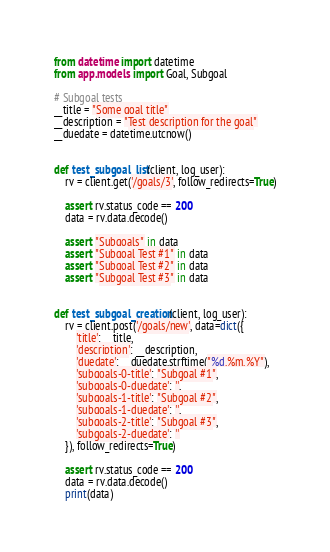<code> <loc_0><loc_0><loc_500><loc_500><_Python_>from datetime import datetime
from app.models import Goal, Subgoal

# Subgoal tests
__title = "Some goal title"
__description = "Test description for the goal"
__duedate = datetime.utcnow()


def test_subgoal_list(client, log_user):
    rv = client.get('/goals/3', follow_redirects=True)

    assert rv.status_code == 200
    data = rv.data.decode()

    assert "Subgoals" in data
    assert "Subgoal Test #1" in data
    assert "Subgoal Test #2" in data
    assert "Subgoal Test #3" in data


def test_subgoal_creation(client, log_user):
    rv = client.post('/goals/new', data=dict({
        'title': __title,
        'description': __description,
        'duedate': __duedate.strftime("%d.%m.%Y"),
        'subgoals-0-title': "Subgoal #1",
        'subgoals-0-duedate': '',
        'subgoals-1-title': "Subgoal #2",
        'subgoals-1-duedate': '',
        'subgoals-2-title': "Subgoal #3",
        'subgoals-2-duedate': ''
    }), follow_redirects=True)

    assert rv.status_code == 200
    data = rv.data.decode()
    print(data)
</code> 